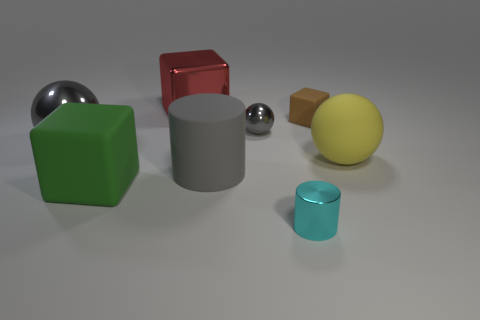Subtract all gray spheres. How many were subtracted if there are1gray spheres left? 1 Add 2 small green rubber cylinders. How many objects exist? 10 Subtract all cubes. How many objects are left? 5 Subtract 0 purple blocks. How many objects are left? 8 Subtract all tiny gray spheres. Subtract all rubber cylinders. How many objects are left? 6 Add 7 big gray things. How many big gray things are left? 9 Add 5 large red shiny blocks. How many large red shiny blocks exist? 6 